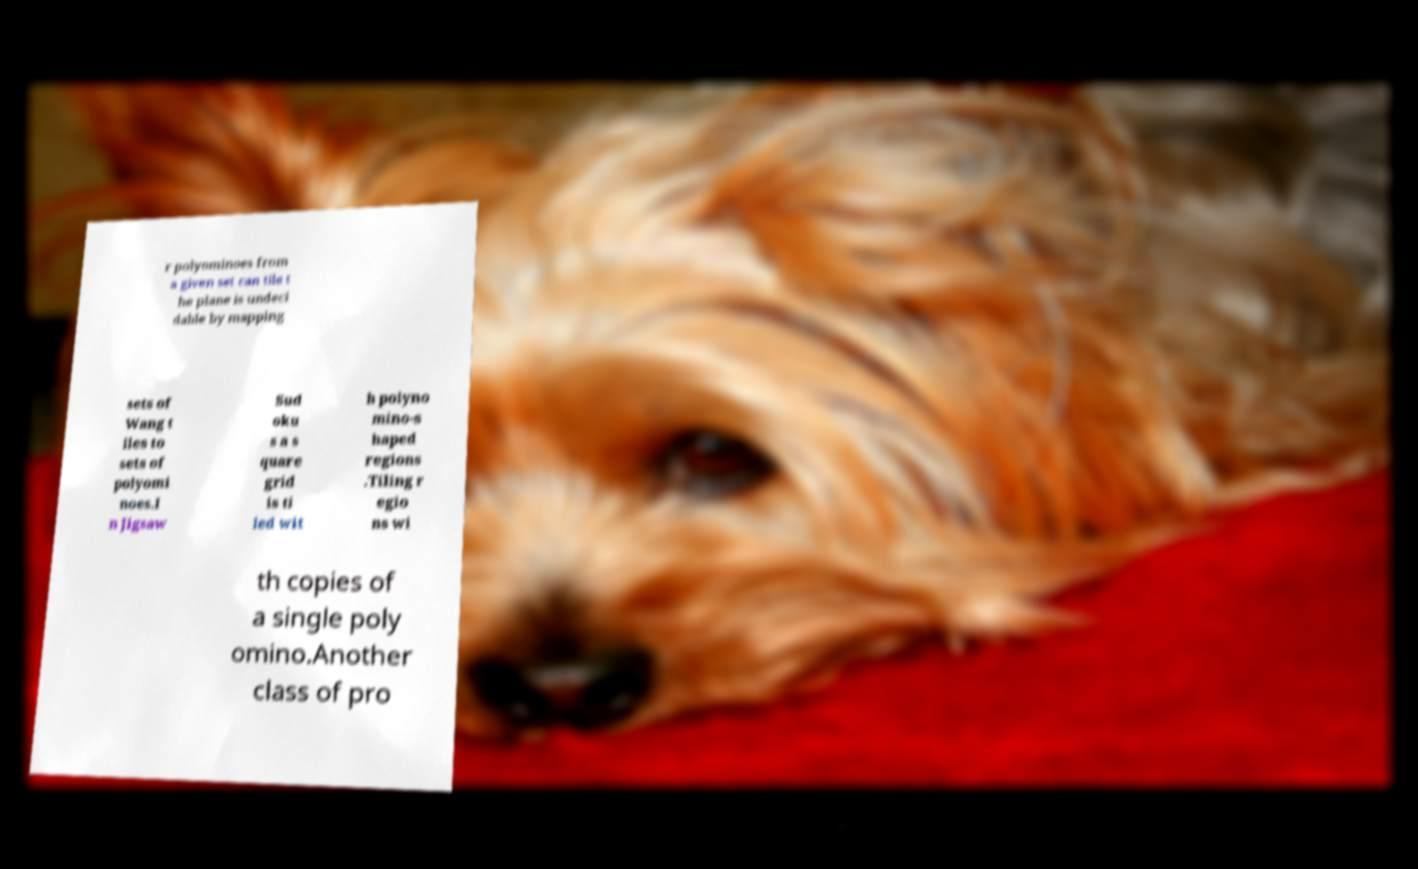Could you assist in decoding the text presented in this image and type it out clearly? r polyominoes from a given set can tile t he plane is undeci dable by mapping sets of Wang t iles to sets of polyomi noes.I n Jigsaw Sud oku s a s quare grid is ti led wit h polyno mino-s haped regions .Tiling r egio ns wi th copies of a single poly omino.Another class of pro 